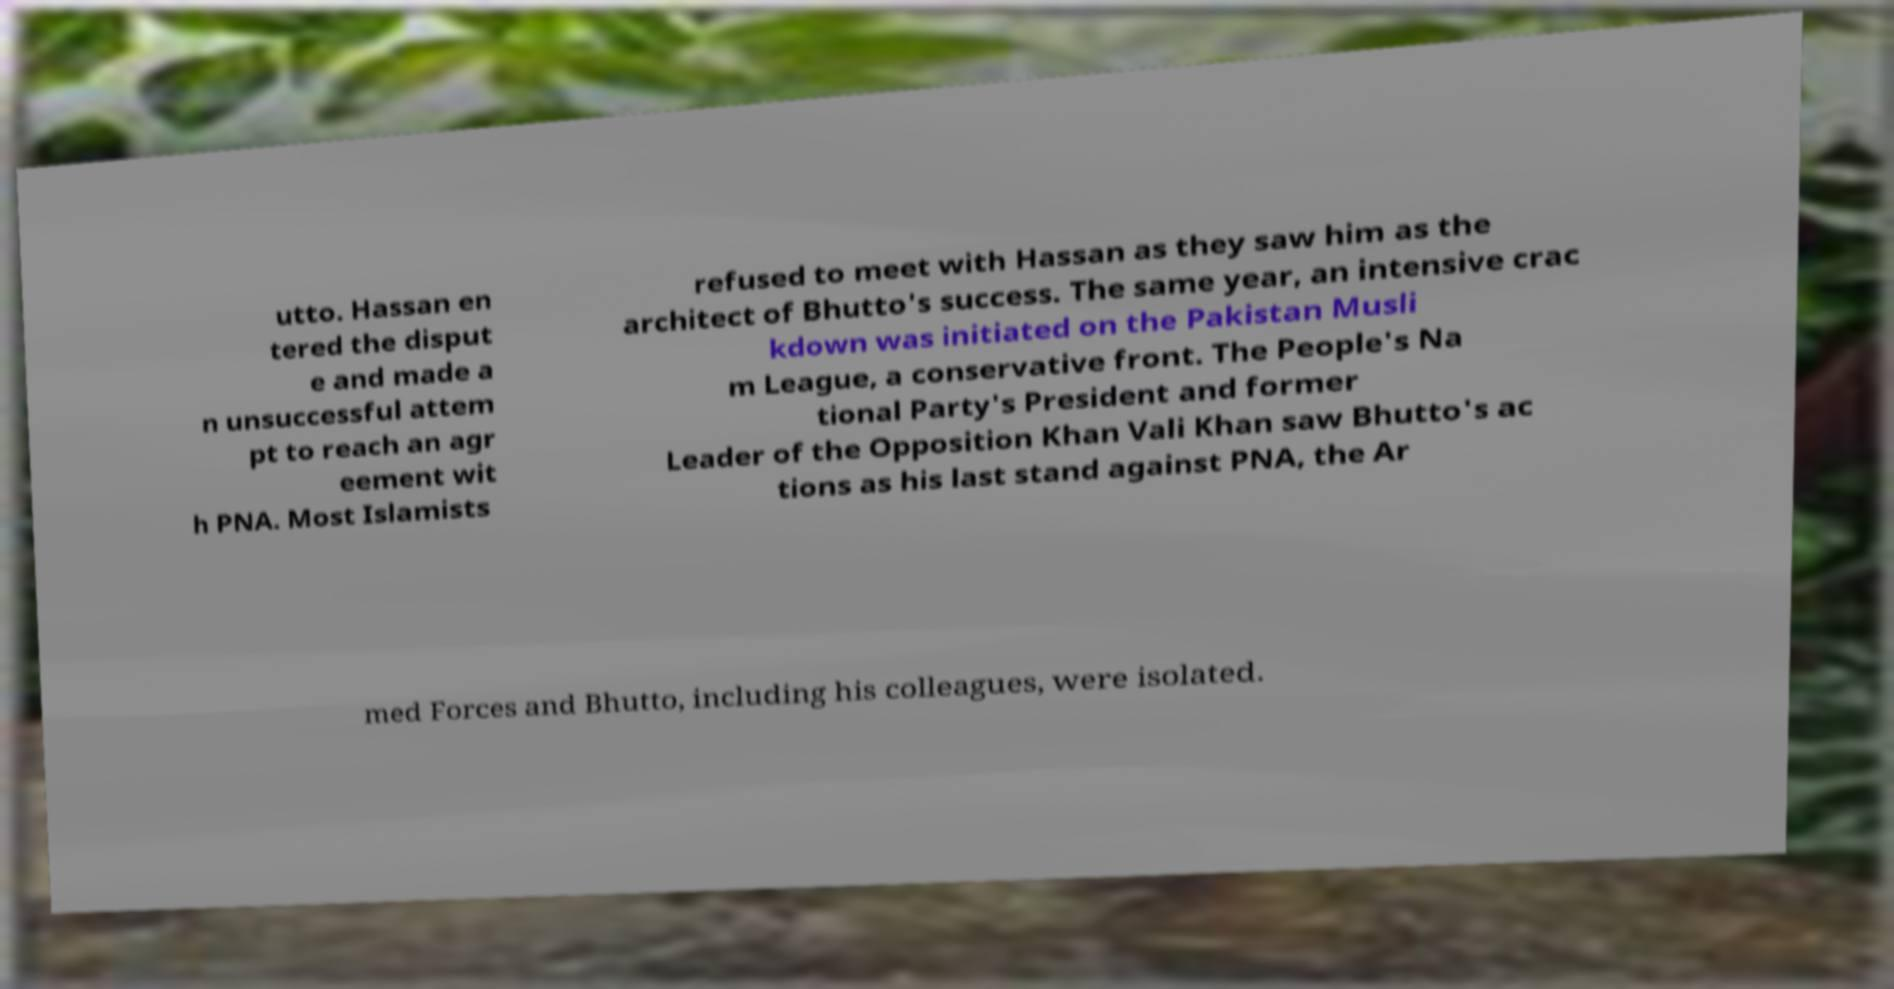What messages or text are displayed in this image? I need them in a readable, typed format. utto. Hassan en tered the disput e and made a n unsuccessful attem pt to reach an agr eement wit h PNA. Most Islamists refused to meet with Hassan as they saw him as the architect of Bhutto's success. The same year, an intensive crac kdown was initiated on the Pakistan Musli m League, a conservative front. The People's Na tional Party's President and former Leader of the Opposition Khan Vali Khan saw Bhutto's ac tions as his last stand against PNA, the Ar med Forces and Bhutto, including his colleagues, were isolated. 